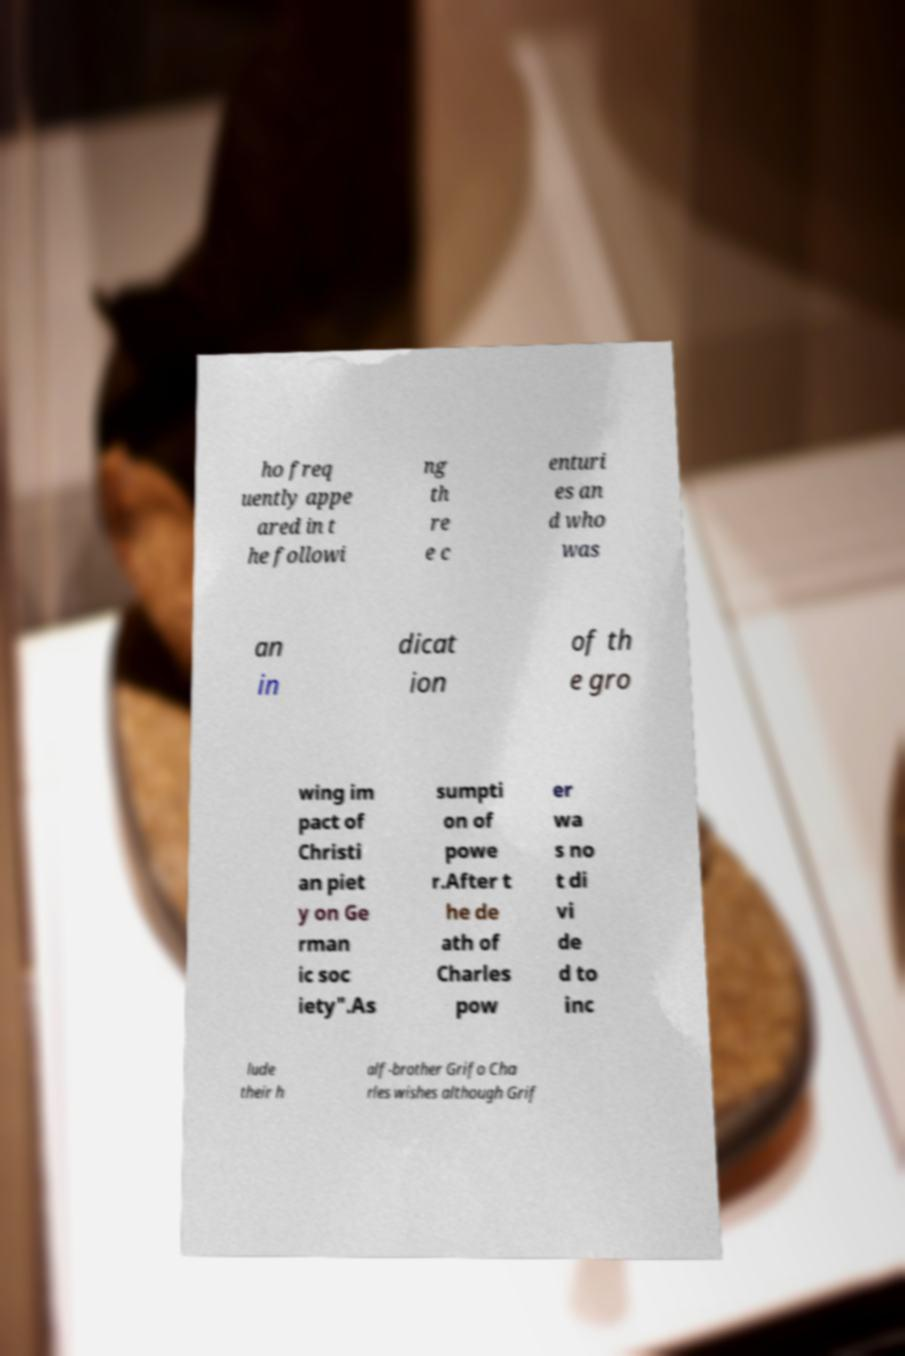I need the written content from this picture converted into text. Can you do that? ho freq uently appe ared in t he followi ng th re e c enturi es an d who was an in dicat ion of th e gro wing im pact of Christi an piet y on Ge rman ic soc iety".As sumpti on of powe r.After t he de ath of Charles pow er wa s no t di vi de d to inc lude their h alf-brother Grifo Cha rles wishes although Grif 